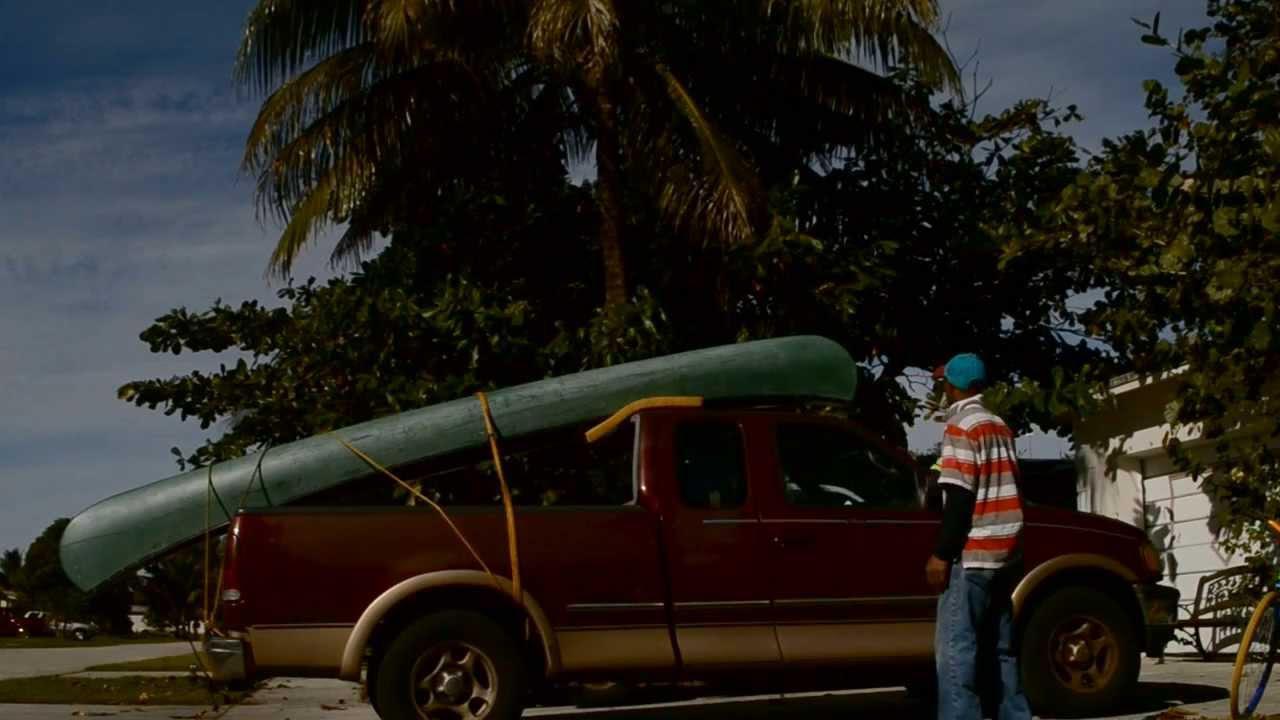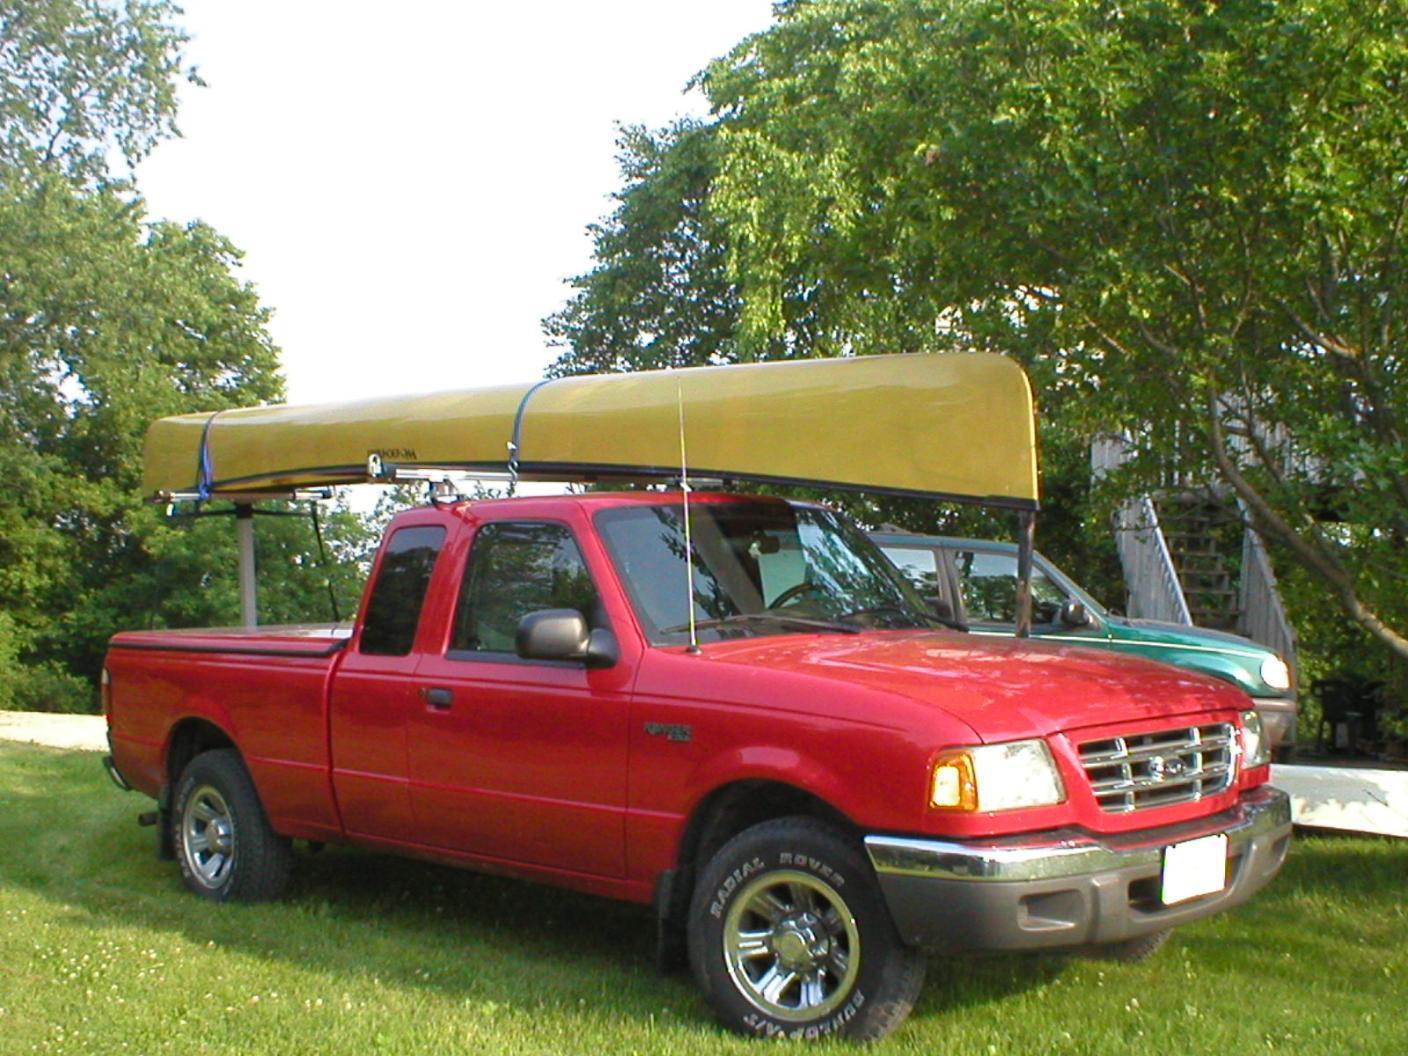The first image is the image on the left, the second image is the image on the right. Given the left and right images, does the statement "A vehicle in one image is loaded with more than one boat." hold true? Answer yes or no. No. 